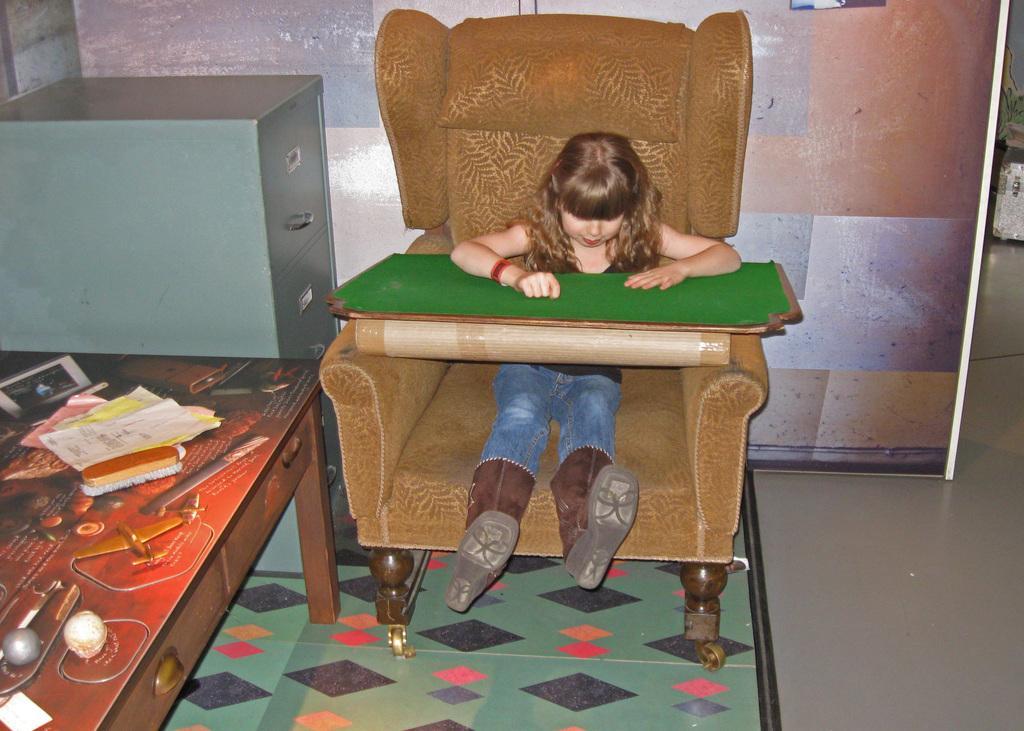In one or two sentences, can you explain what this image depicts? This girl is sitting on a couch. In-front of this girl there is a green color board. This is a cupboard. On a table there is a brush and papers. Wall is colorful. 